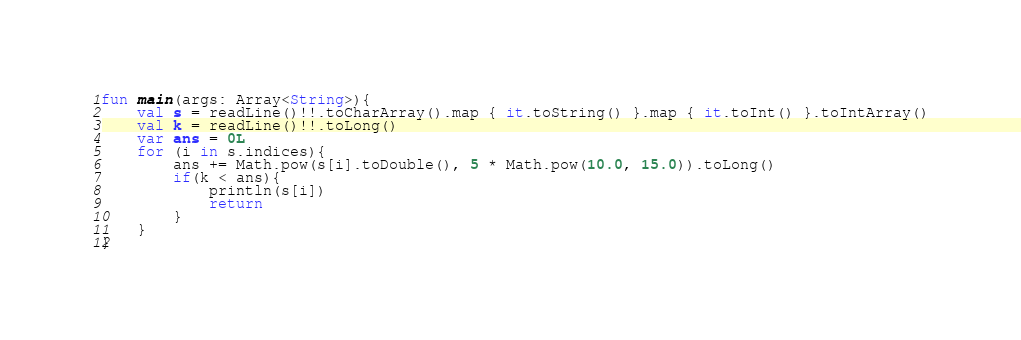Convert code to text. <code><loc_0><loc_0><loc_500><loc_500><_Kotlin_>fun main(args: Array<String>){
    val s = readLine()!!.toCharArray().map { it.toString() }.map { it.toInt() }.toIntArray()
    val k = readLine()!!.toLong()
    var ans = 0L
    for (i in s.indices){
        ans += Math.pow(s[i].toDouble(), 5 * Math.pow(10.0, 15.0)).toLong()
        if(k < ans){
            println(s[i])
            return
        }
    }
}</code> 